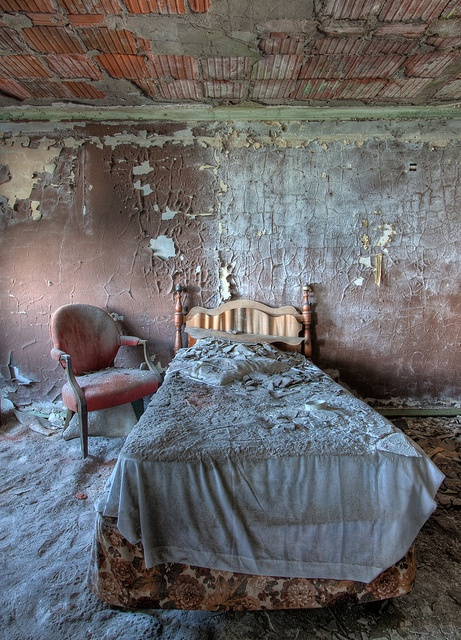Describe the objects in this image and their specific colors. I can see bed in maroon, gray, and black tones and chair in maroon, gray, black, and darkgray tones in this image. 